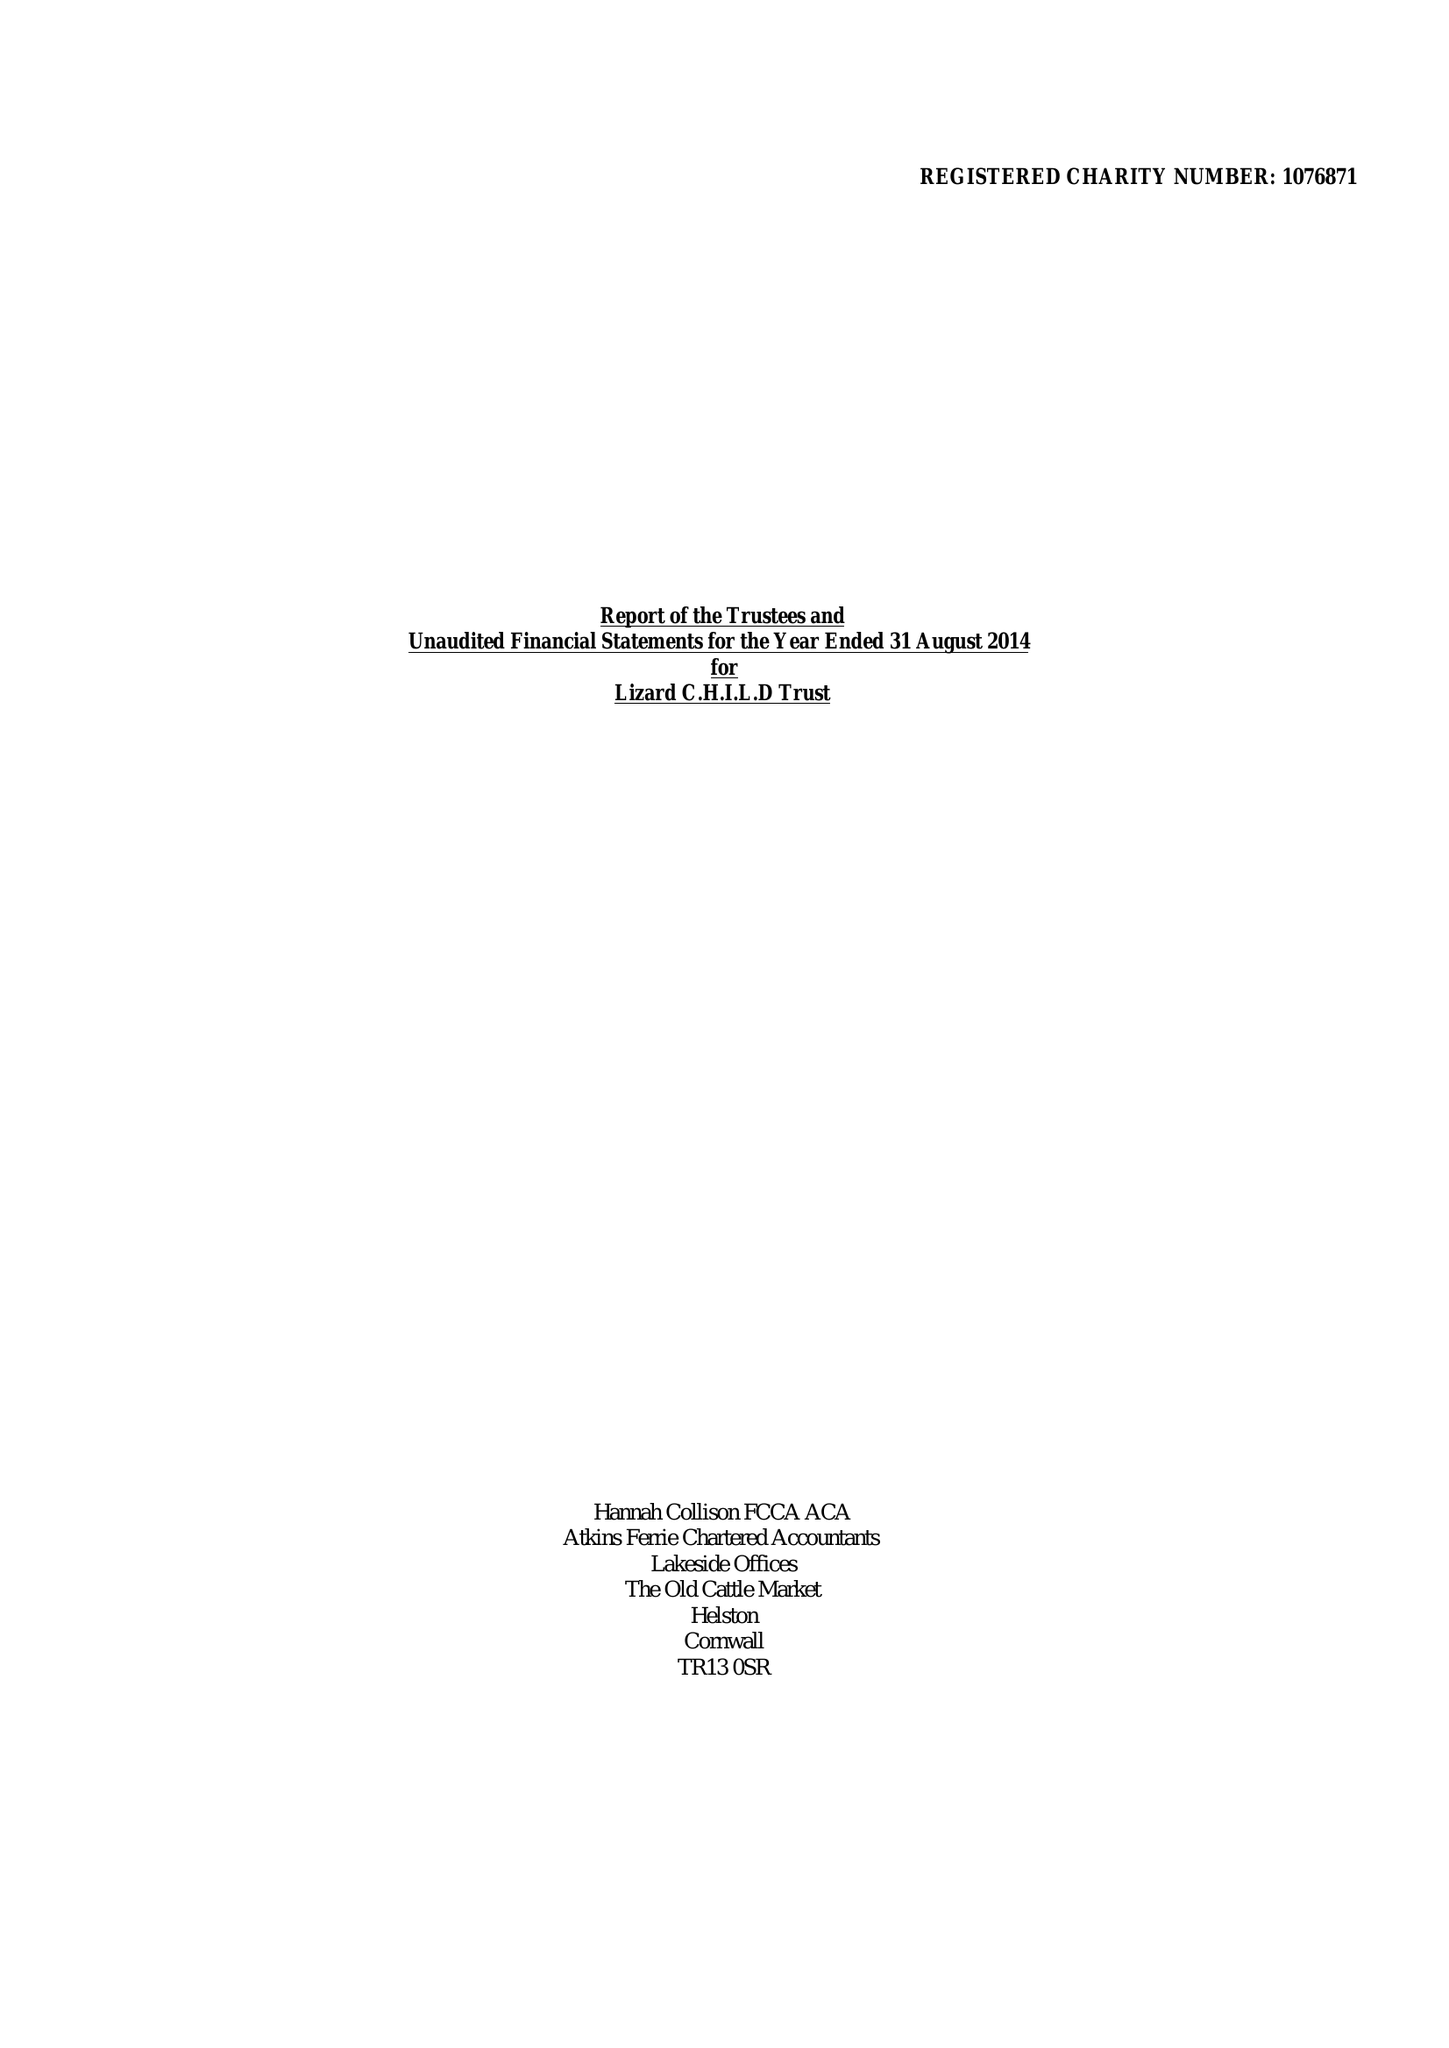What is the value for the income_annually_in_british_pounds?
Answer the question using a single word or phrase. 252963.00 